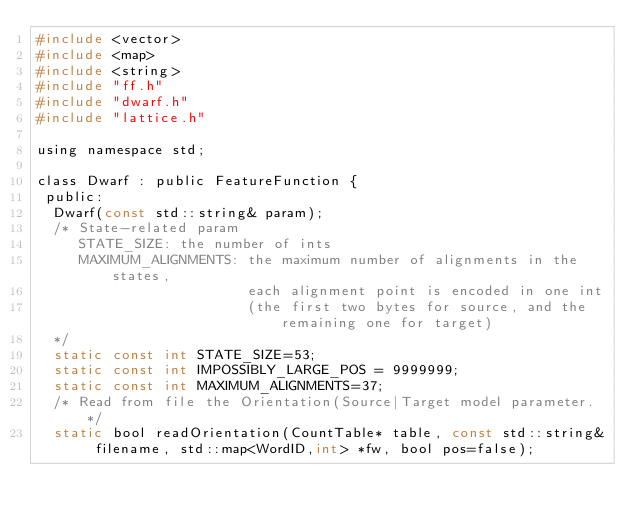Convert code to text. <code><loc_0><loc_0><loc_500><loc_500><_C_>#include <vector>
#include <map>
#include <string>
#include "ff.h"
#include "dwarf.h"
#include "lattice.h"

using namespace std;

class Dwarf : public FeatureFunction {
 public:
  Dwarf(const std::string& param);
  /* State-related param
     STATE_SIZE: the number of ints 
     MAXIMUM_ALIGNMENTS: the maximum number of alignments in the states, 
                         each alignment point is encoded in one int 
                         (the first two bytes for source, and the remaining one for target)
  */
  static const int STATE_SIZE=53; 
  static const int IMPOSSIBLY_LARGE_POS = 9999999;
  static const int MAXIMUM_ALIGNMENTS=37;
  /* Read from file the Orientation(Source|Target model parameter. */ 
  static bool readOrientation(CountTable* table, const std::string& filename, std::map<WordID,int> *fw, bool pos=false);</code> 